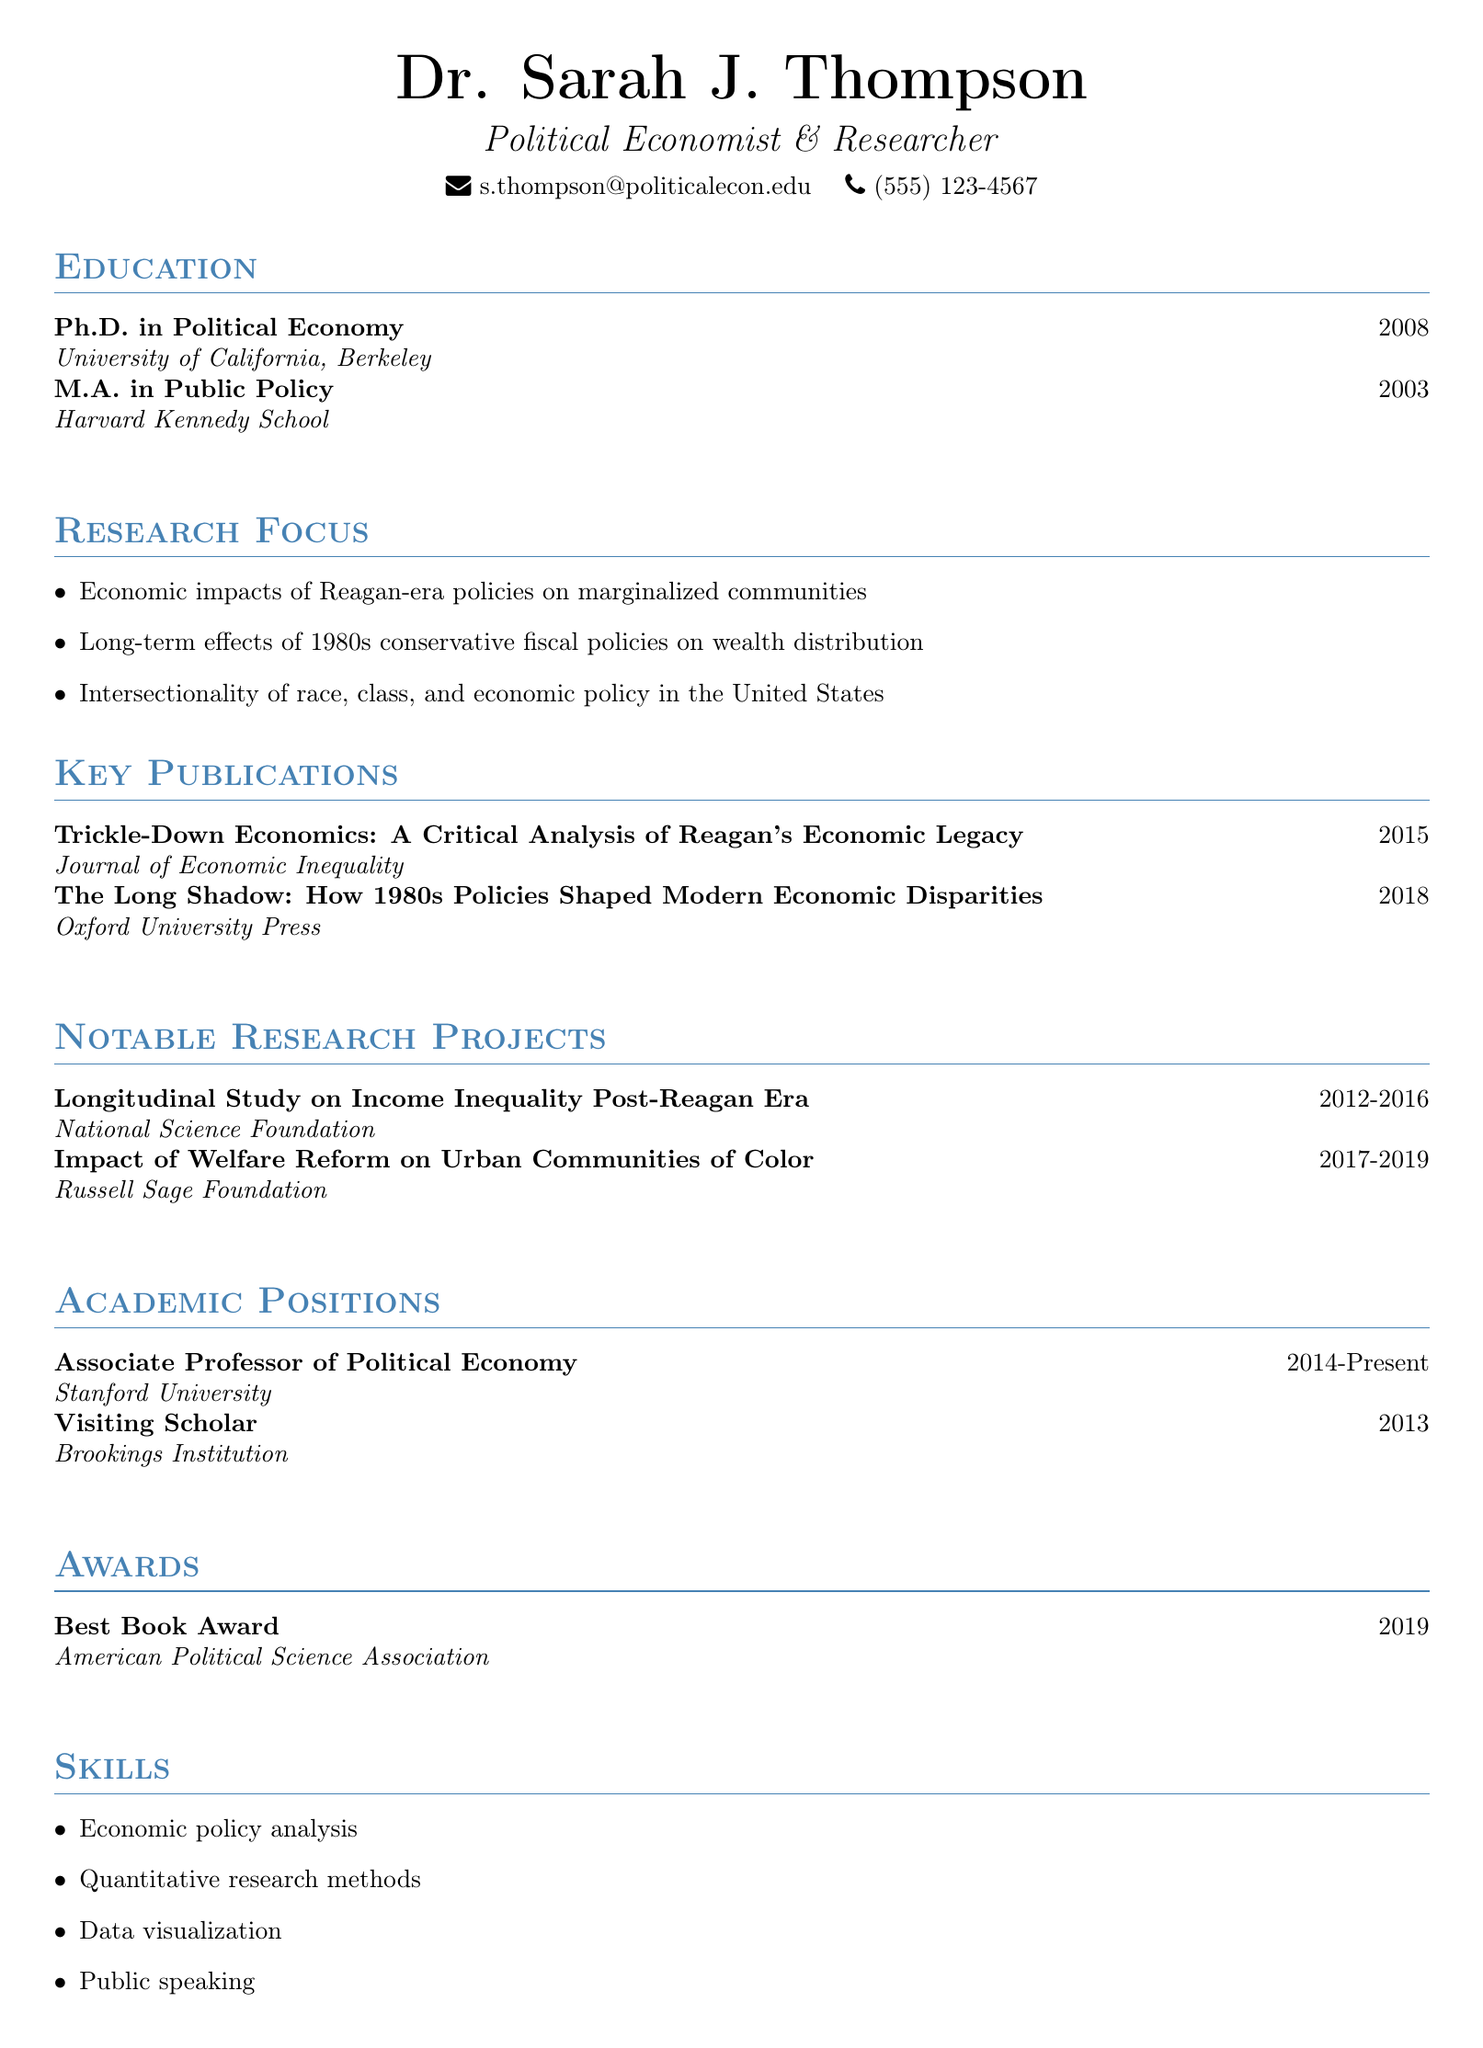What is the name of the researcher? The document states the researcher’s name as Dr. Sarah J. Thompson.
Answer: Dr. Sarah J. Thompson In which year did Dr. Thompson complete her Ph.D.? The document specifies that the Ph.D. was completed in 2008.
Answer: 2008 What is the title of Dr. Thompson's book published in 2018? The title of the book published in 2018 is "The Long Shadow: How 1980s Policies Shaped Modern Economic Disparities."
Answer: The Long Shadow: How 1980s Policies Shaped Modern Economic Disparities How many years did the Longitudinal Study on Income Inequality last? The project funded by the National Science Foundation lasted four years, from 2012 to 2016.
Answer: Four years What award did Dr. Thompson receive in 2019? The document lists the Best Book Award from the American Political Science Association as an accolade received in 2019.
Answer: Best Book Award What is one of the key focuses of Dr. Thompson’s research? The document mentions the economic impacts of Reagan-era policies on marginalized communities as one of the key focuses.
Answer: Economic impacts of Reagan-era policies on marginalized communities Which academic institution does Dr. Thompson currently work at? The document states that Dr. Thompson is an Associate Professor at Stanford University.
Answer: Stanford University What type of research methods is Dr. Thompson skilled in? According to the document, she is skilled in quantitative research methods.
Answer: Quantitative research methods 